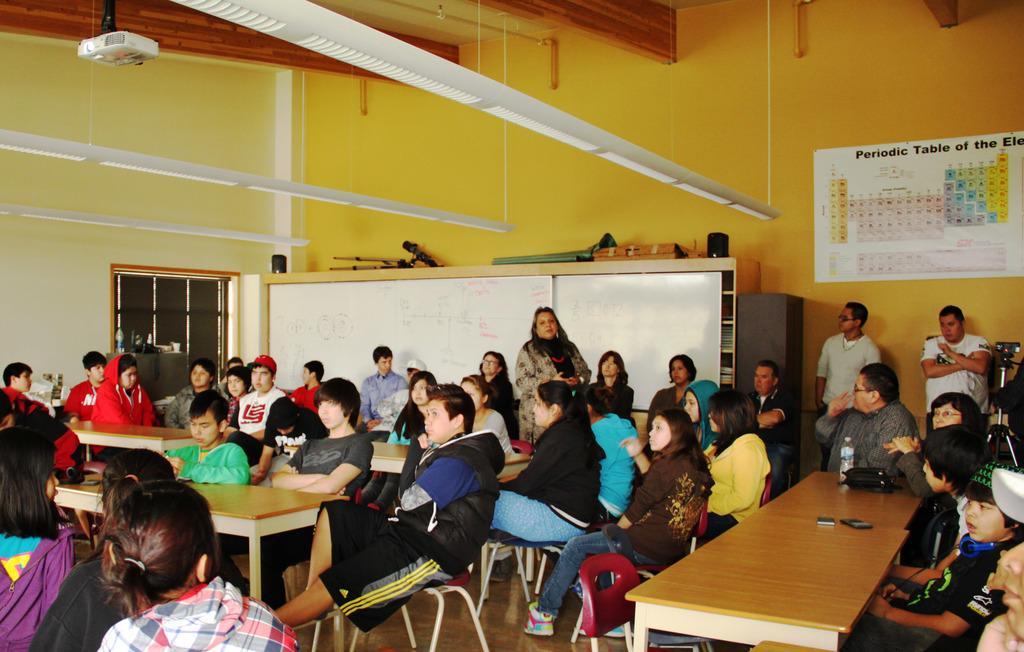Describe this image in one or two sentences. In this picture there are group of people those who are sitting and there are tables in front of them there is a projector above the area of the image, it seems to be a class room, there is a door at he left side of the image. 